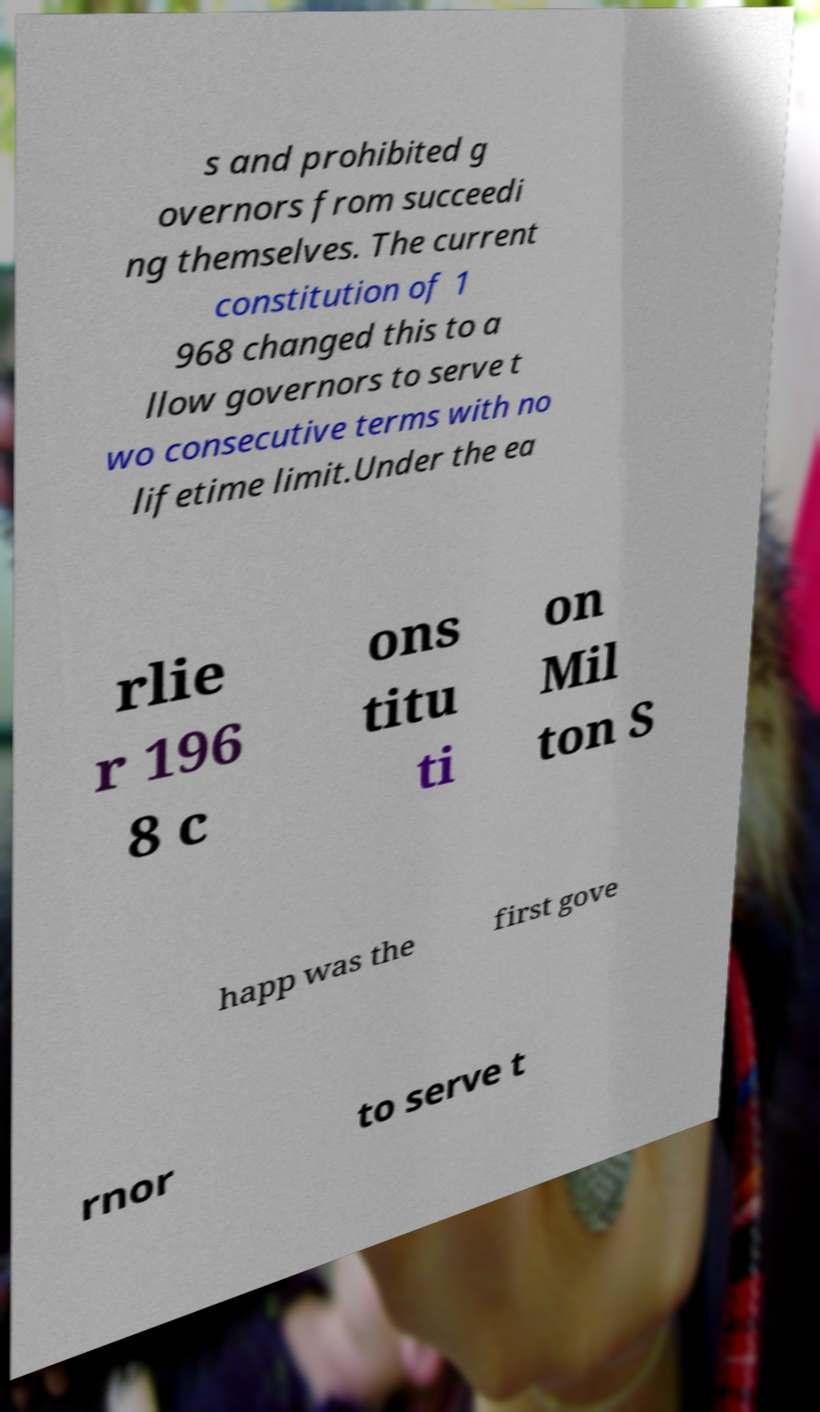Please identify and transcribe the text found in this image. s and prohibited g overnors from succeedi ng themselves. The current constitution of 1 968 changed this to a llow governors to serve t wo consecutive terms with no lifetime limit.Under the ea rlie r 196 8 c ons titu ti on Mil ton S happ was the first gove rnor to serve t 